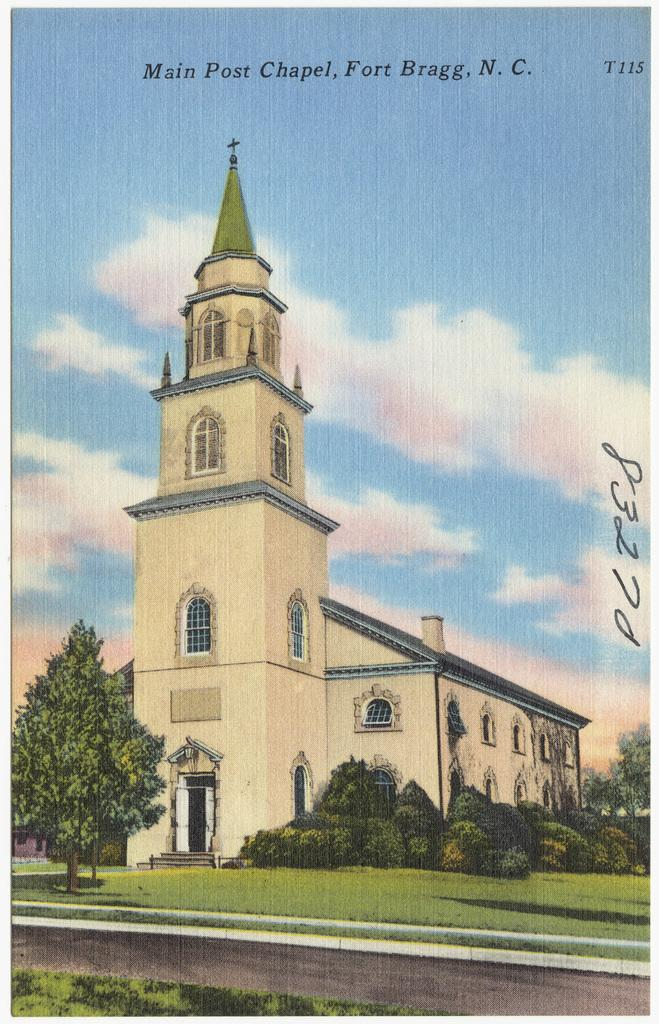What is the main subject in the center of the image? There is a building in the center of the image. What can be seen in the background of the image? There are trees in the background of the image. What is visible in the sky in the image? There are clouds in the sky. What is written or displayed in the image? There is some text visible in the image. What is at the bottom of the image? There is ground at the bottom of the image. What is the opinion of the sun in the image? There is no sun present in the image, so it is not possible to determine its opinion. 